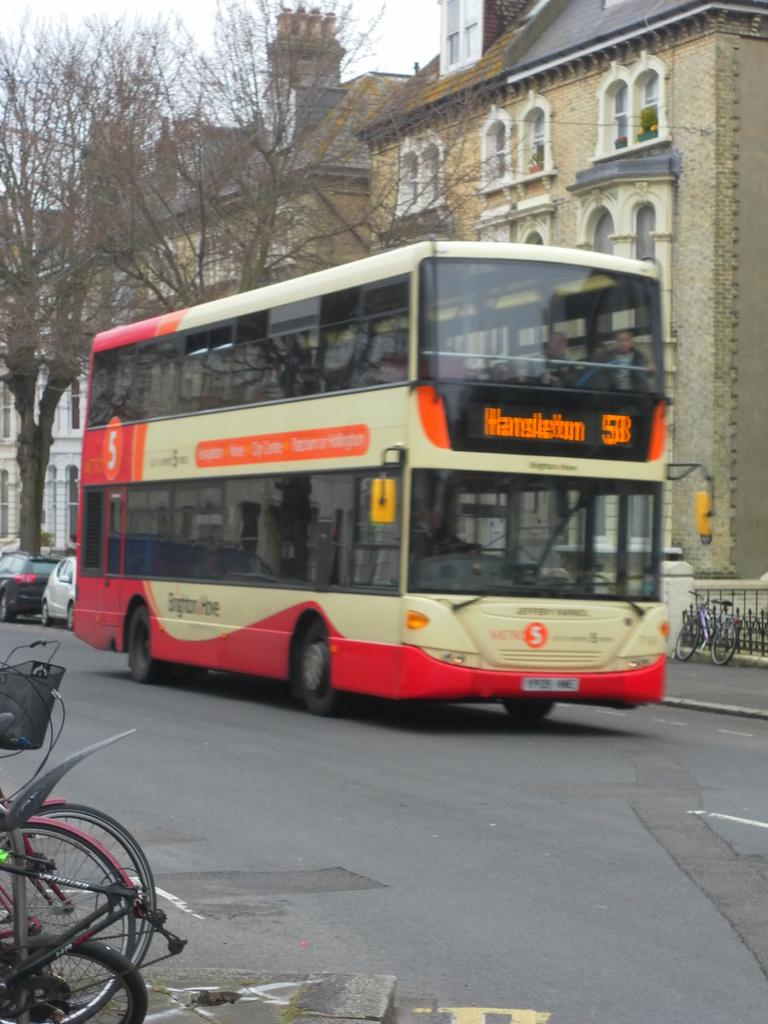What is the main subject in the center of the image? There is a bus in the center of the image. What can be seen in the background of the image? There are trees, buildings, and vehicles in the background of the image. What type of oatmeal is being served on the bus in the image? There is no oatmeal present in the image; it features a bus and its surroundings. 